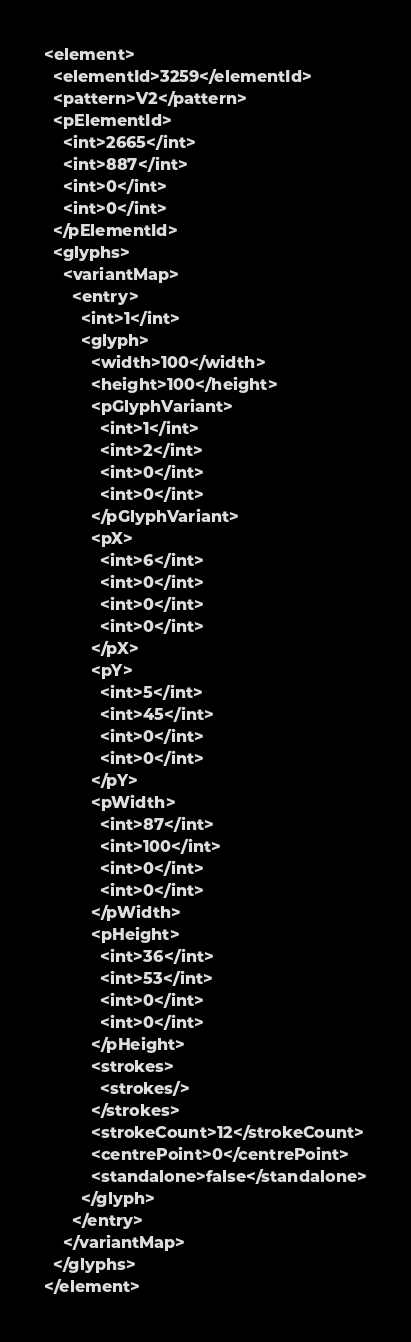Convert code to text. <code><loc_0><loc_0><loc_500><loc_500><_XML_><element>
  <elementId>3259</elementId>
  <pattern>V2</pattern>
  <pElementId>
    <int>2665</int>
    <int>887</int>
    <int>0</int>
    <int>0</int>
  </pElementId>
  <glyphs>
    <variantMap>
      <entry>
        <int>1</int>
        <glyph>
          <width>100</width>
          <height>100</height>
          <pGlyphVariant>
            <int>1</int>
            <int>2</int>
            <int>0</int>
            <int>0</int>
          </pGlyphVariant>
          <pX>
            <int>6</int>
            <int>0</int>
            <int>0</int>
            <int>0</int>
          </pX>
          <pY>
            <int>5</int>
            <int>45</int>
            <int>0</int>
            <int>0</int>
          </pY>
          <pWidth>
            <int>87</int>
            <int>100</int>
            <int>0</int>
            <int>0</int>
          </pWidth>
          <pHeight>
            <int>36</int>
            <int>53</int>
            <int>0</int>
            <int>0</int>
          </pHeight>
          <strokes>
            <strokes/>
          </strokes>
          <strokeCount>12</strokeCount>
          <centrePoint>0</centrePoint>
          <standalone>false</standalone>
        </glyph>
      </entry>
    </variantMap>
  </glyphs>
</element></code> 